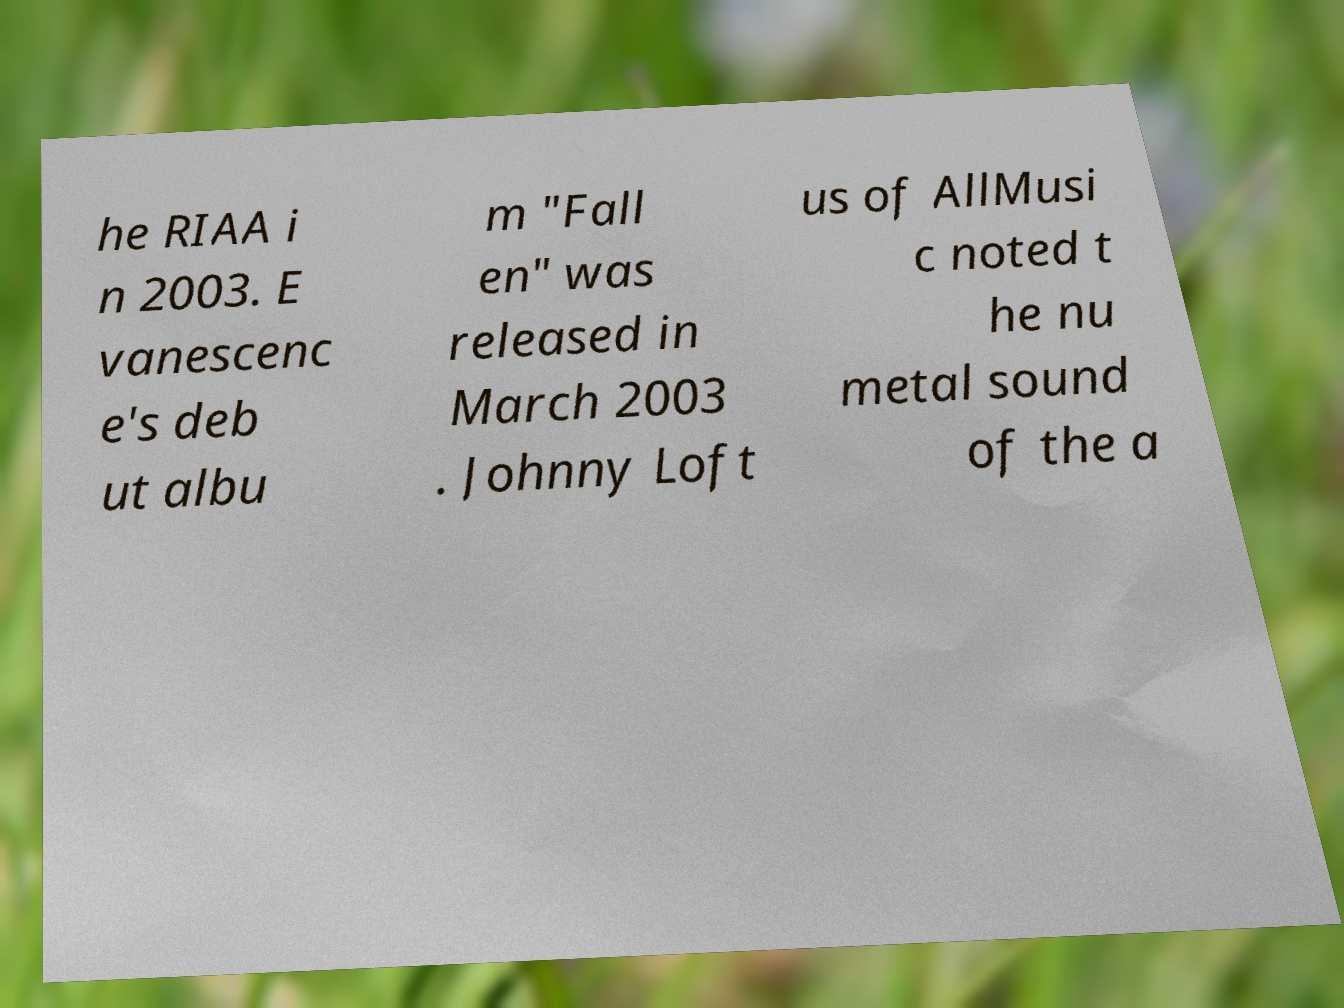I need the written content from this picture converted into text. Can you do that? he RIAA i n 2003. E vanescenc e's deb ut albu m "Fall en" was released in March 2003 . Johnny Loft us of AllMusi c noted t he nu metal sound of the a 